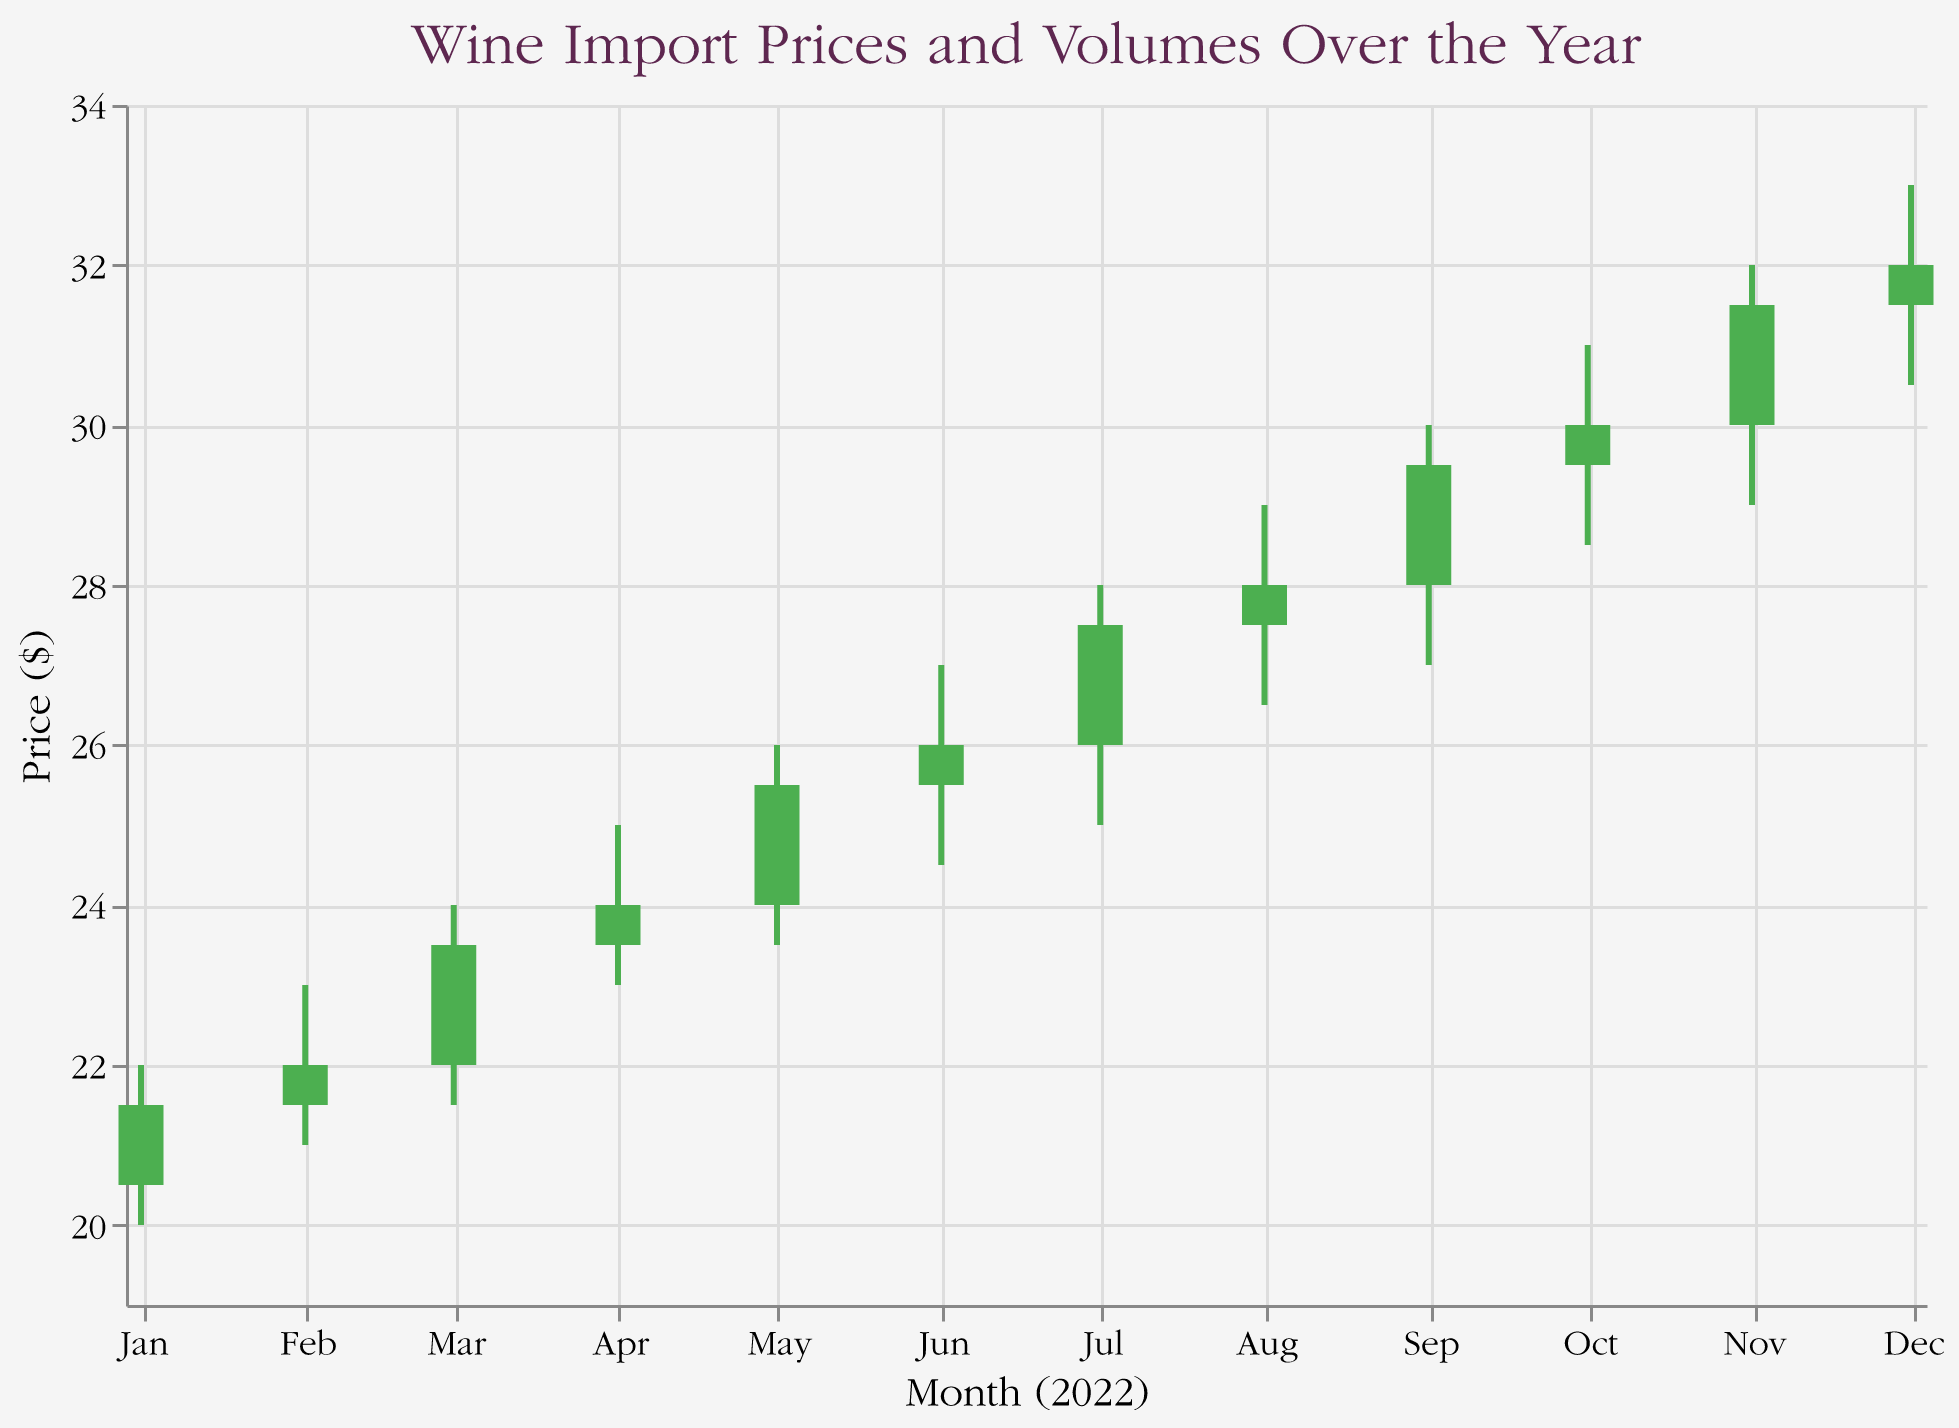What is the title of the chart? The title of the chart is positioned at the top and clearly states the subject being visualized.
Answer: Wine Import Prices and Volumes Over the Year What are the axes representing? The x-axis represents the months of the year 2022, formatted as abbreviated month names. The y-axis represents the price in dollars.
Answer: x-axis: Month (2022), y-axis: Price ($) How does the color of the bars indicate price movement? The color of the bars changes based on whether the closing price is higher or lower than the opening price: green for an upward movement (Open < Close) and red for a downward movement (Open > Close).
Answer: Green for upward, red for downward How many data points show an increase in the closing price compared to the opening price? A green bar indicates an increase in the closing price compared to the opening price. By counting the green bars in the figure, you can determine the number of increases.
Answer: 12 Which month shows the highest volume? The volume data for each month can be compared to determine which has the highest value. The highest volume is 2600 in December.
Answer: December What is the lowest price recorded throughout the year? The lowest price is the lowest 'Low' value visible in the chart, which is found in January.
Answer: $20.00 In which month did the price close the highest, and what was the value? The highest closing price can be observed on the y-axis by examining the 'Close' values for each month. The highest closing price is in December at $32.00.
Answer: December, $32.00 During which month did the price fluctuate the most, and what was the range? The price fluctuation range can be calculated by subtracting the 'Low' value from the 'High' value for each month. The month with the highest range (33.00 - 30.50 = 2.50) is December.
Answer: December, $2.50 How did the volume trend throughout the year, increasing, decreasing, or stable? To see the volume trend over time, observe the 'Volume' values from January to December. The volume consistently increases each month.
Answer: Increasing What was the price difference between the open and close values in May? For May, subtract the 'Open' value from the 'Close' value to find the price difference (25.50 - 24.00 = 1.50).
Answer: $1.50 